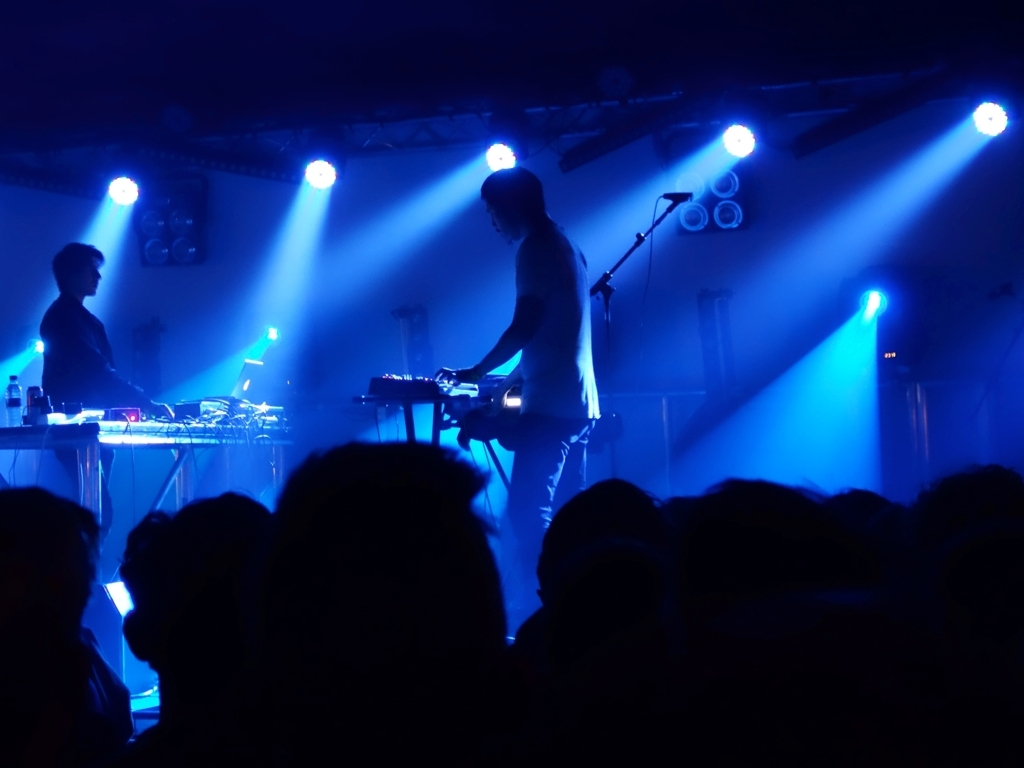What emotions or atmosphere does this image evoke? The combination of blue stage lighting and the hazy silhouette of the audience evokes an atmospheric, immersive vibe typical for a live music experience, suggesting excitement and anticipation among the audience. Could you describe the lighting in the photo? Certainly, the lighting appears to be low and concentrated on stage with the strategic use of spotlights and blue hues, creating stark contrasts and dramatic shadows. It's both moody and dynamic, contributing to the overall ambience. 